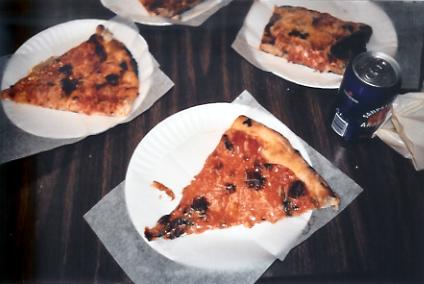Is the pizza on paper plates?
Quick response, please. Yes. How many pieces of square pizza are in this picture?
Keep it brief. 1. What are the black things on the pizza?
Give a very brief answer. Olives. 